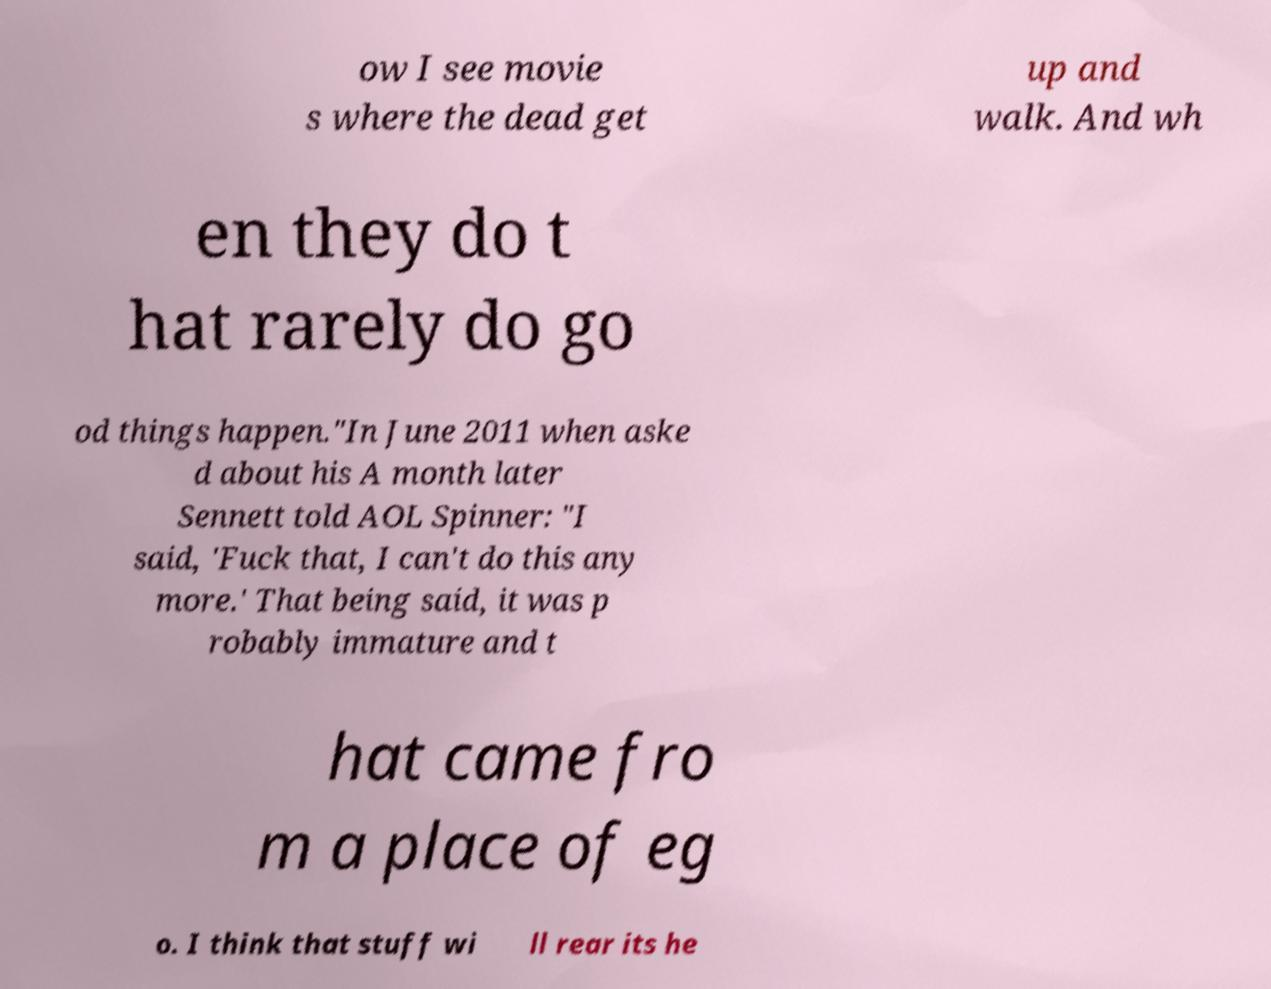Could you assist in decoding the text presented in this image and type it out clearly? ow I see movie s where the dead get up and walk. And wh en they do t hat rarely do go od things happen."In June 2011 when aske d about his A month later Sennett told AOL Spinner: "I said, 'Fuck that, I can't do this any more.' That being said, it was p robably immature and t hat came fro m a place of eg o. I think that stuff wi ll rear its he 